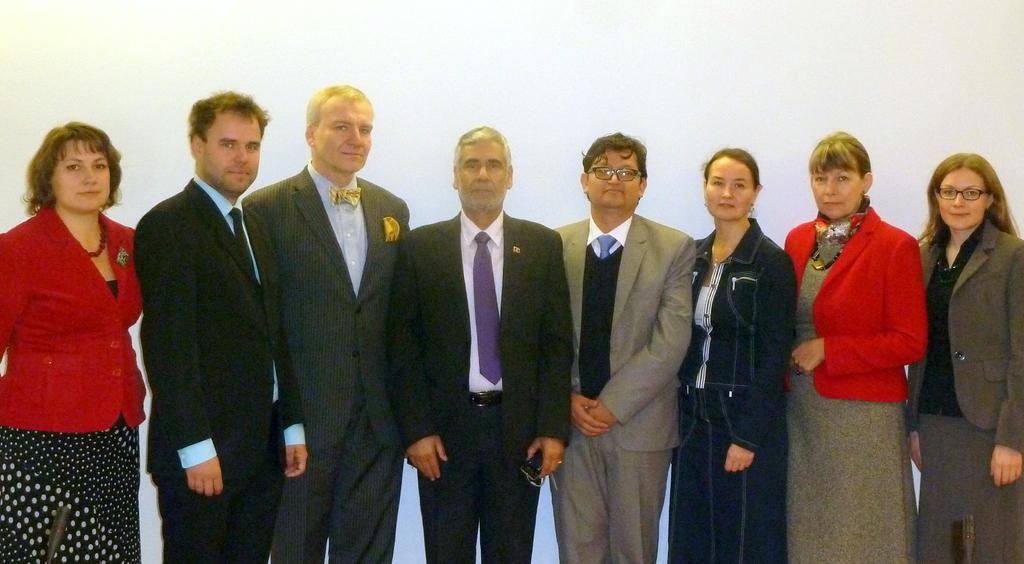In one or two sentences, can you explain what this image depicts? In this picture we can see group of people, they are all standing, and few people wore spectacles, in front of them we can see few microphones. 